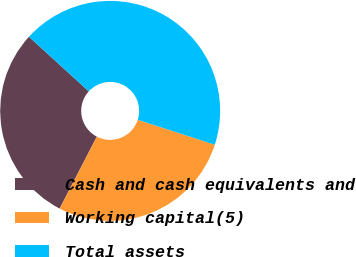<chart> <loc_0><loc_0><loc_500><loc_500><pie_chart><fcel>Cash and cash equivalents and<fcel>Working capital(5)<fcel>Total assets<nl><fcel>29.18%<fcel>27.62%<fcel>43.2%<nl></chart> 